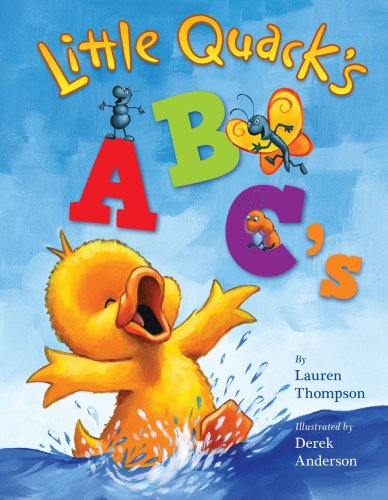What is the genre of this book? 'Little Quack's ABC's' falls under the genre of Children's Books, specifically designed to educate and entertain young readers with fun alphabetic adventures. 